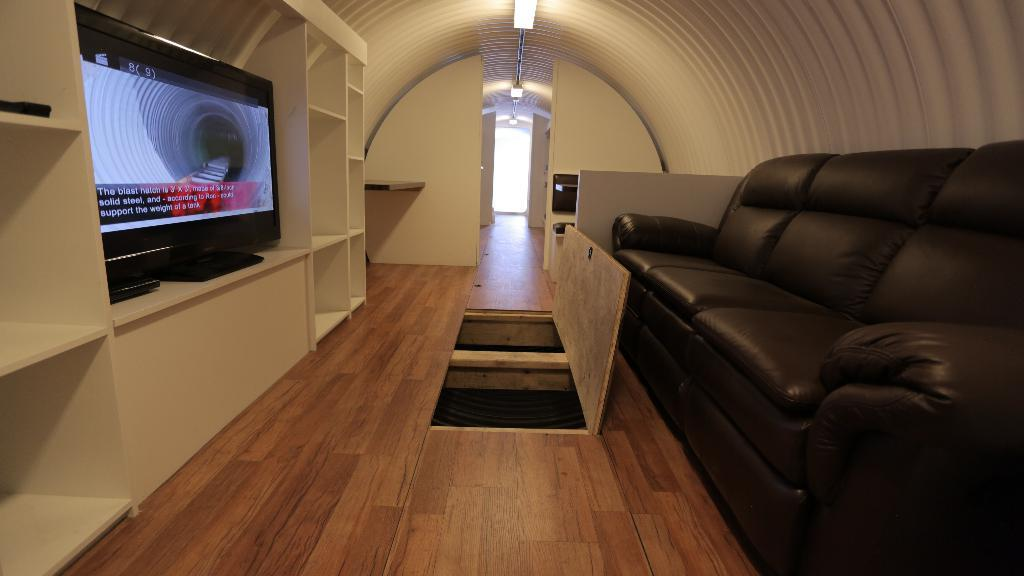Where was the image taken? The image was taken inside a room. What furniture is on the right side of the room? There is a sofa on the right side of the room. What is on the left side of the room? There is a TV on a cabinet on the left side of the room. What object is on the floor in the image? There is a box-like structure on the floor. What type of wine is being served on the sofa in the image? There is no wine present in the image; it only shows a sofa, a TV, a cabinet, and a box-like structure on the floor. 